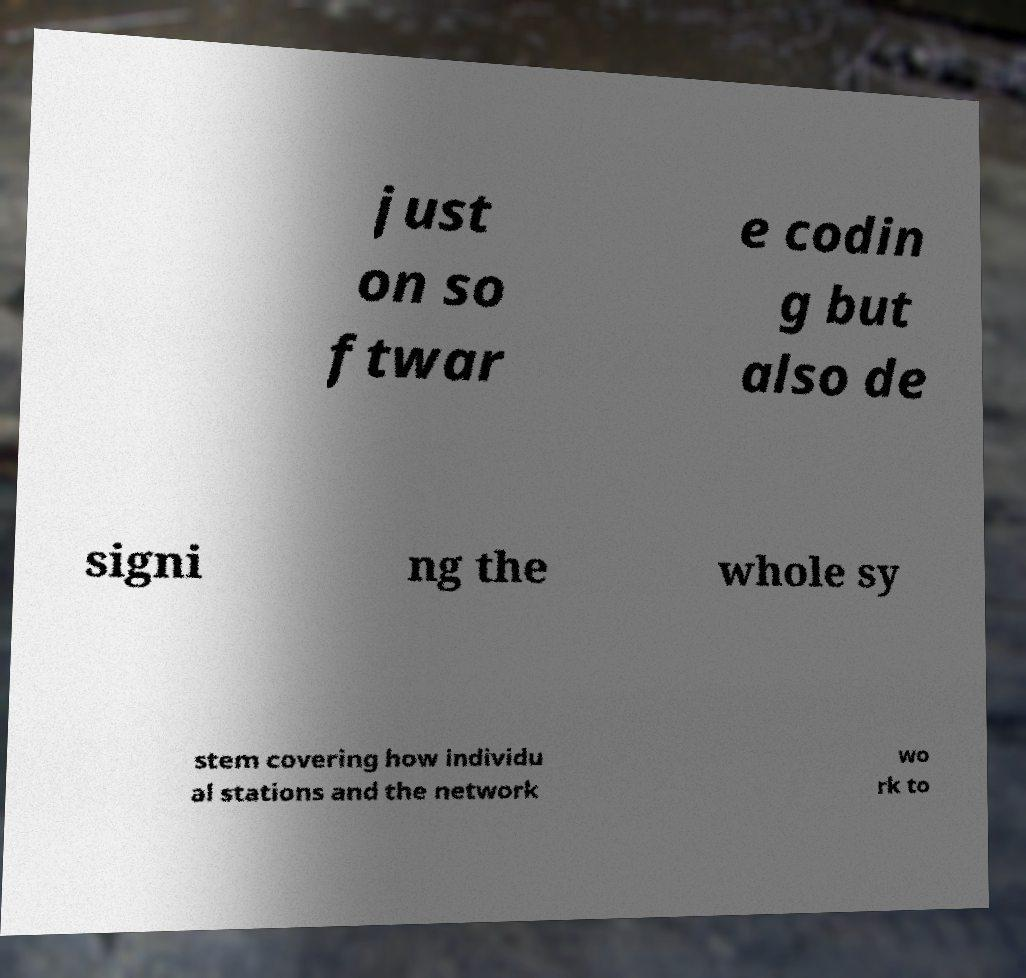There's text embedded in this image that I need extracted. Can you transcribe it verbatim? just on so ftwar e codin g but also de signi ng the whole sy stem covering how individu al stations and the network wo rk to 